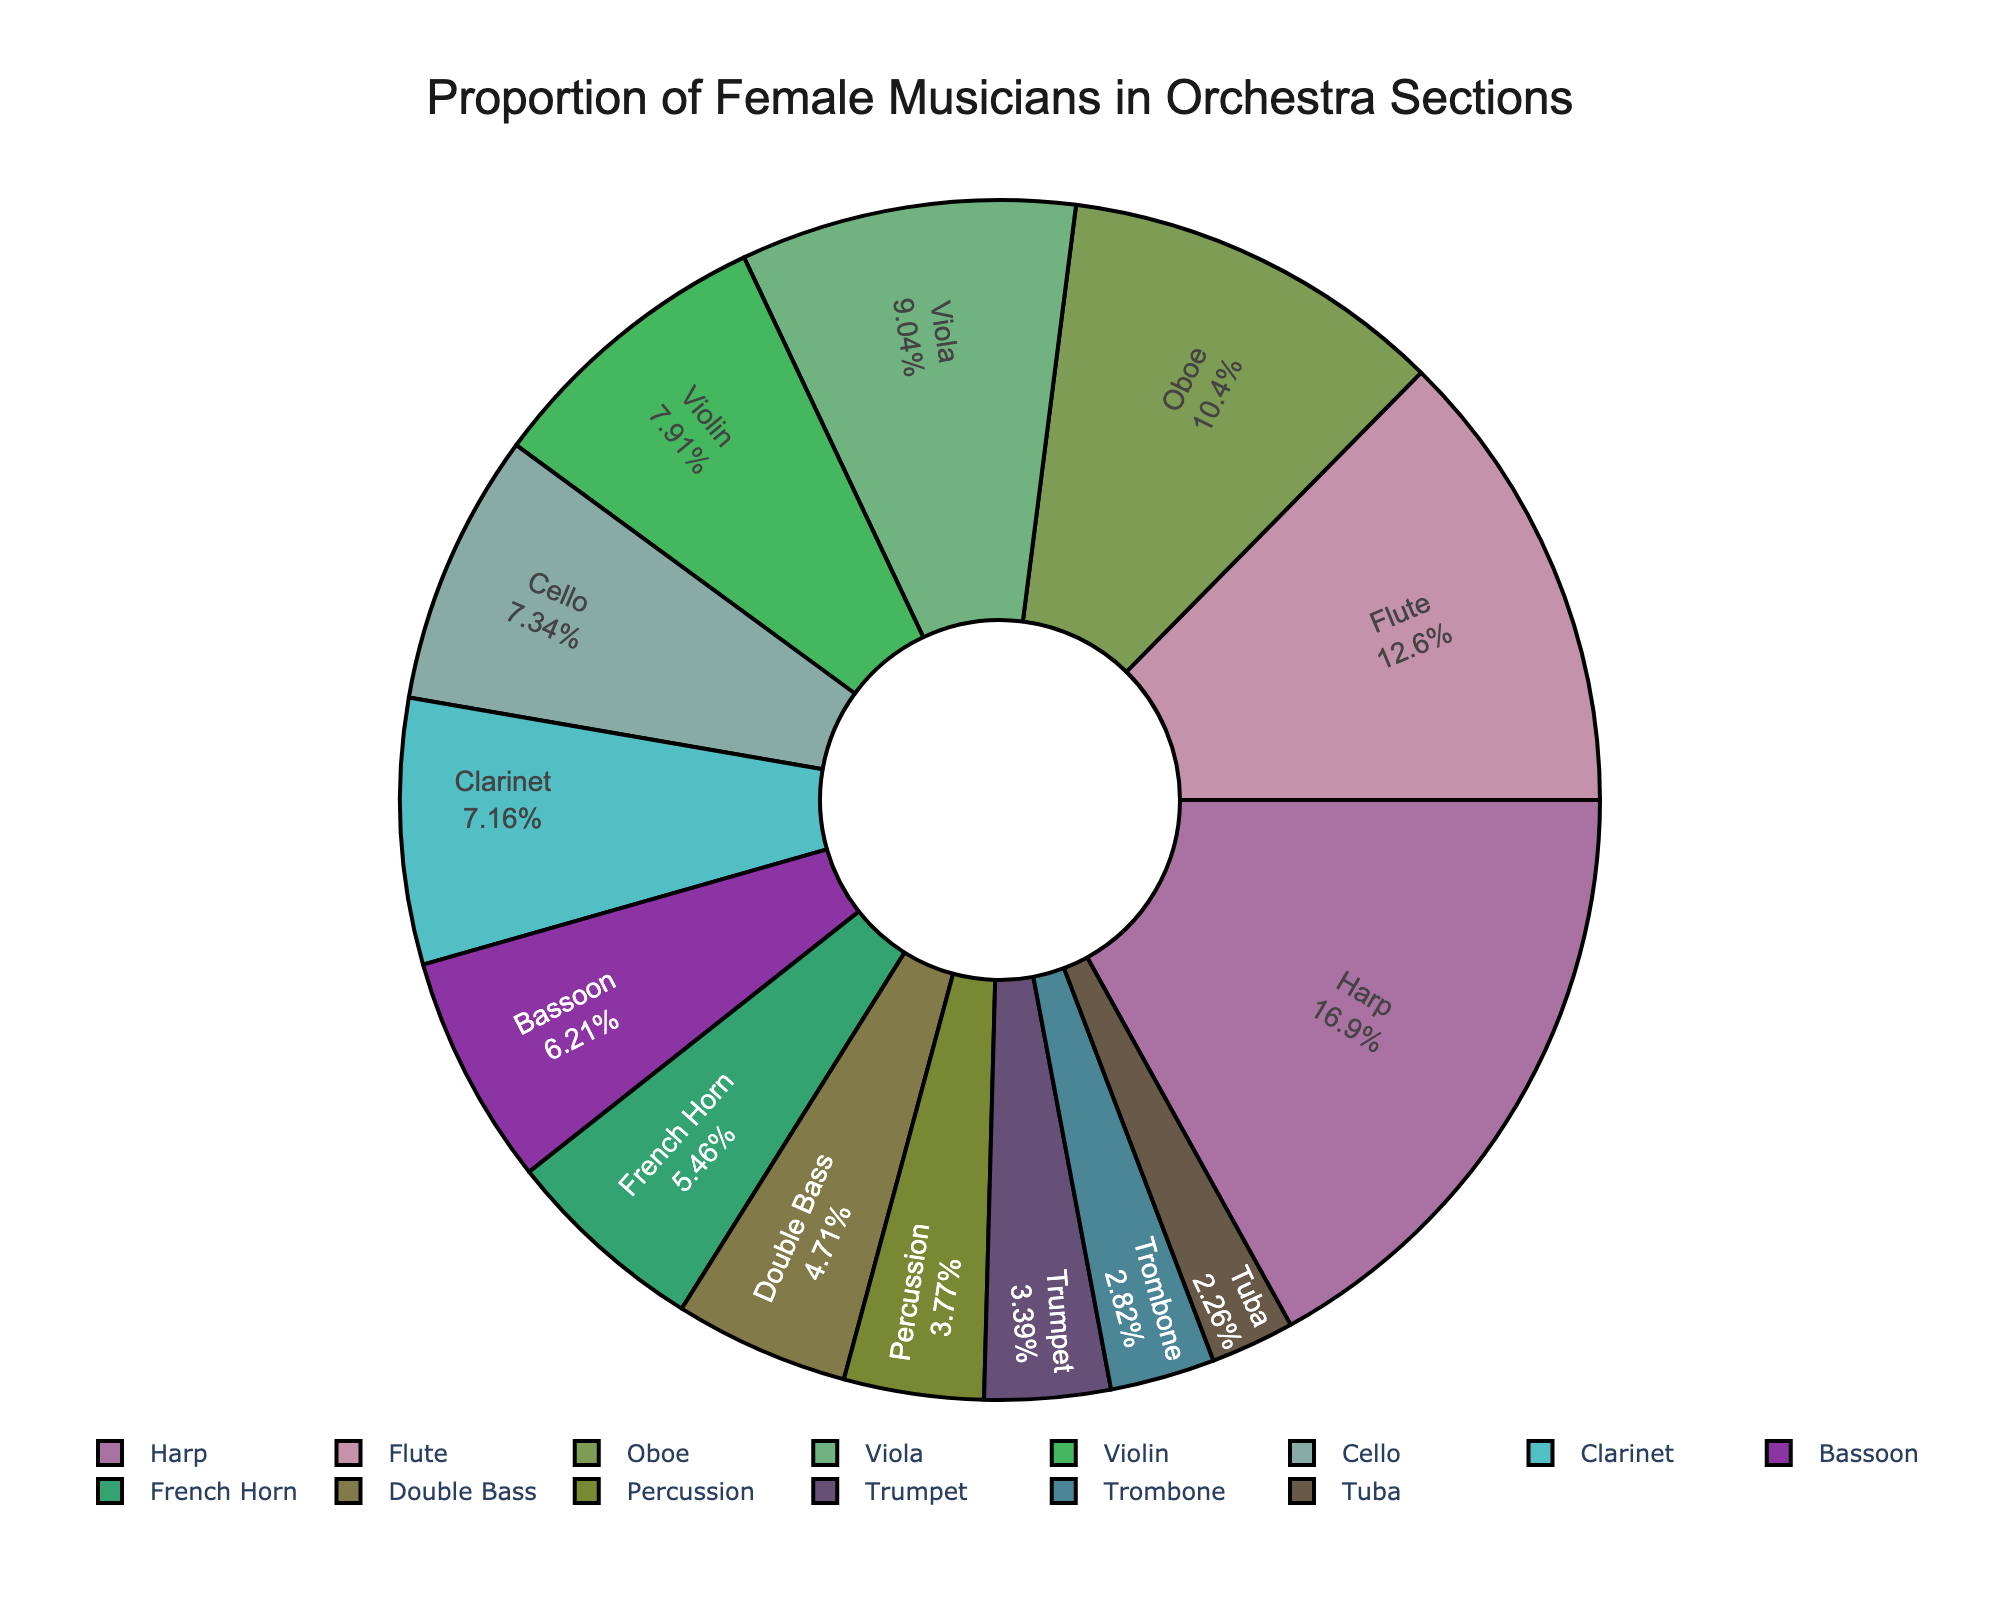What section has the highest proportion of female musicians? The "Harp" section has the highest proportion of female musicians based on the highest percentage value (90%) in the pie chart.
Answer: Harp Which section has a higher percentage of female musicians, Violin or Clarinet? The Violin section has 42%, while the Clarinet section has 38%. Therefore, the Violin section has a higher percentage of female musicians than the Clarinet section.
Answer: Violin What is the percentage difference between the Flute and Trombone sections? The percentage of female musicians in the Flute section is 67%, and in the Trombone section, it is 15%. The difference is 67% - 15% = 52%.
Answer: 52% How much higher is the percentage of female musicians in the Oboe section than in the Trumpet section? The Oboe section has 55% and the Trumpet section has 18%. The difference is 55% - 18% = 37%.
Answer: 37% What is the median percentage of female musicians across all sections? To find the median, list the percentages in order: 12, 15, 18, 20, 25, 29, 33, 38, 39, 42, 48, 55, 67, 90. There are 14 values, so the median is the average of the 7th and 8th values: (33 + 38)/2 = 35.5
Answer: 35.5 Which section has fewer female musicians, Double Bass or Tuba? The Double Bass section has 25% female musicians, whereas the Tuba section has 12%. Thus, the Tuba section has fewer female musicians than the Double Bass section.
Answer: Tuba Is the percentage of female musicians in the Percussion section greater than the average percentage of female musicians in the Trombone and Tuba sections? The average percentage for Trombone (15%) and Tuba (12%) is (15 + 12) / 2 = 13.5%. The Percussion section has 20%, which is greater than 13.5%.
Answer: Yes What is the average percentage of female musicians in the string sections (Violin, Viola, Cello, Double Bass)? Add the percentages: 42 + 48 + 39 + 25 = 154. Divide by the number of sections: 154 / 4 = 38.5%.
Answer: 38.5% Which woodwind section has the highest proportion of female musicians? The woodwind sections are Flute, Oboe, Clarinet, and Bassoon. Of these, the Flute section has the highest proportion of female musicians with 67%.
Answer: Flute What is the total percentage of female musicians in the Brass section (French Horn, Trumpet, Trombone, Tuba)? Add the percentages: 29 + 18 + 15 + 12 = 74%.
Answer: 74% 